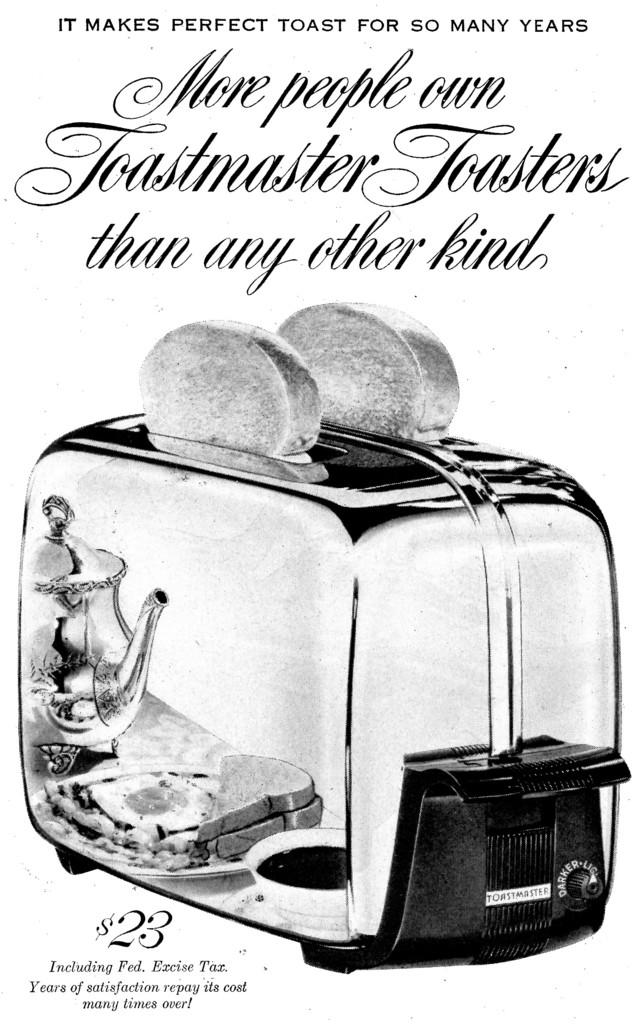What can be seen hanging on the wall in the image? There is a poster in the image. What is written or depicted on the poster? There is some information on the poster. What appliance is visible in the image? There is a bread toaster in the image. How many pairs of trousers are hanging on the bread toaster in the image? There are no trousers present in the image; it features a poster and a bread toaster. What type of cattle can be seen grazing near the poster in the image? There is no cattle present in the image; it only features a poster and a bread toaster. 